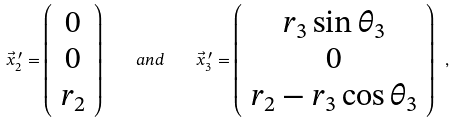Convert formula to latex. <formula><loc_0><loc_0><loc_500><loc_500>\vec { x } ^ { \, \prime } _ { 2 } = \left ( \begin{array} { c } 0 \\ 0 \\ r _ { 2 } \end{array} \right ) \quad a n d \quad \vec { x } ^ { \, \prime } _ { 3 } = \left ( \begin{array} { c } r _ { 3 } \sin \theta _ { 3 } \\ 0 \\ r _ { 2 } - r _ { 3 } \cos \theta _ { 3 } \end{array} \right ) \ ,</formula> 